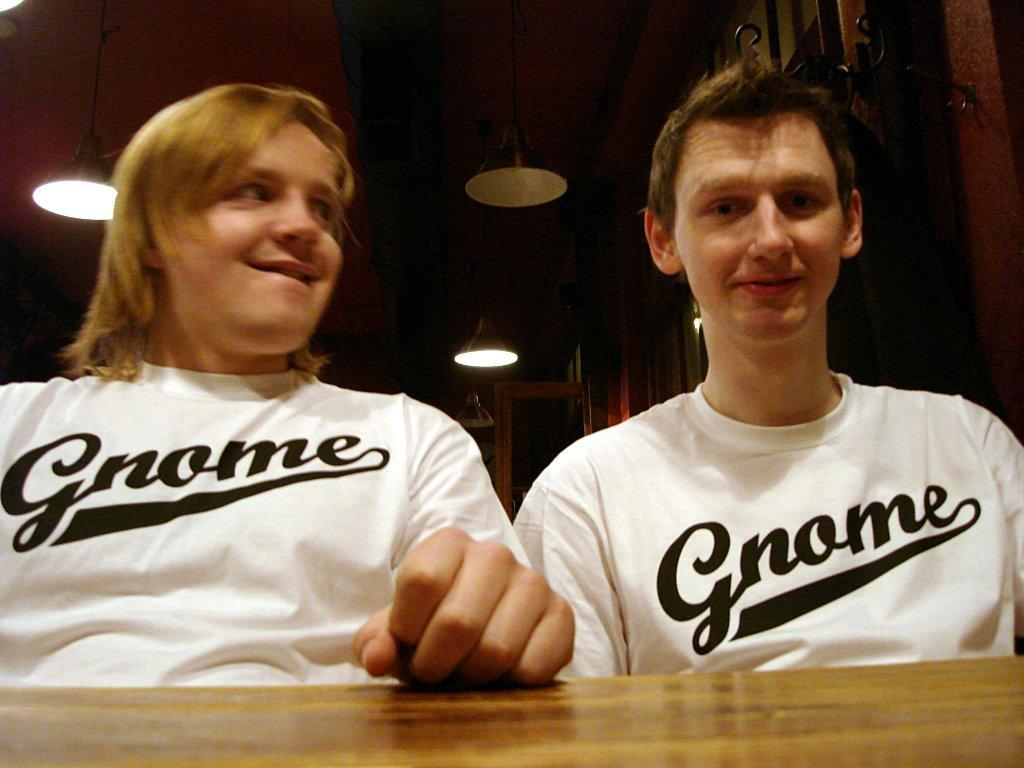Provide a one-sentence caption for the provided image. Two people sitting next to each other with white t-shirts with the word Gnome on them. 